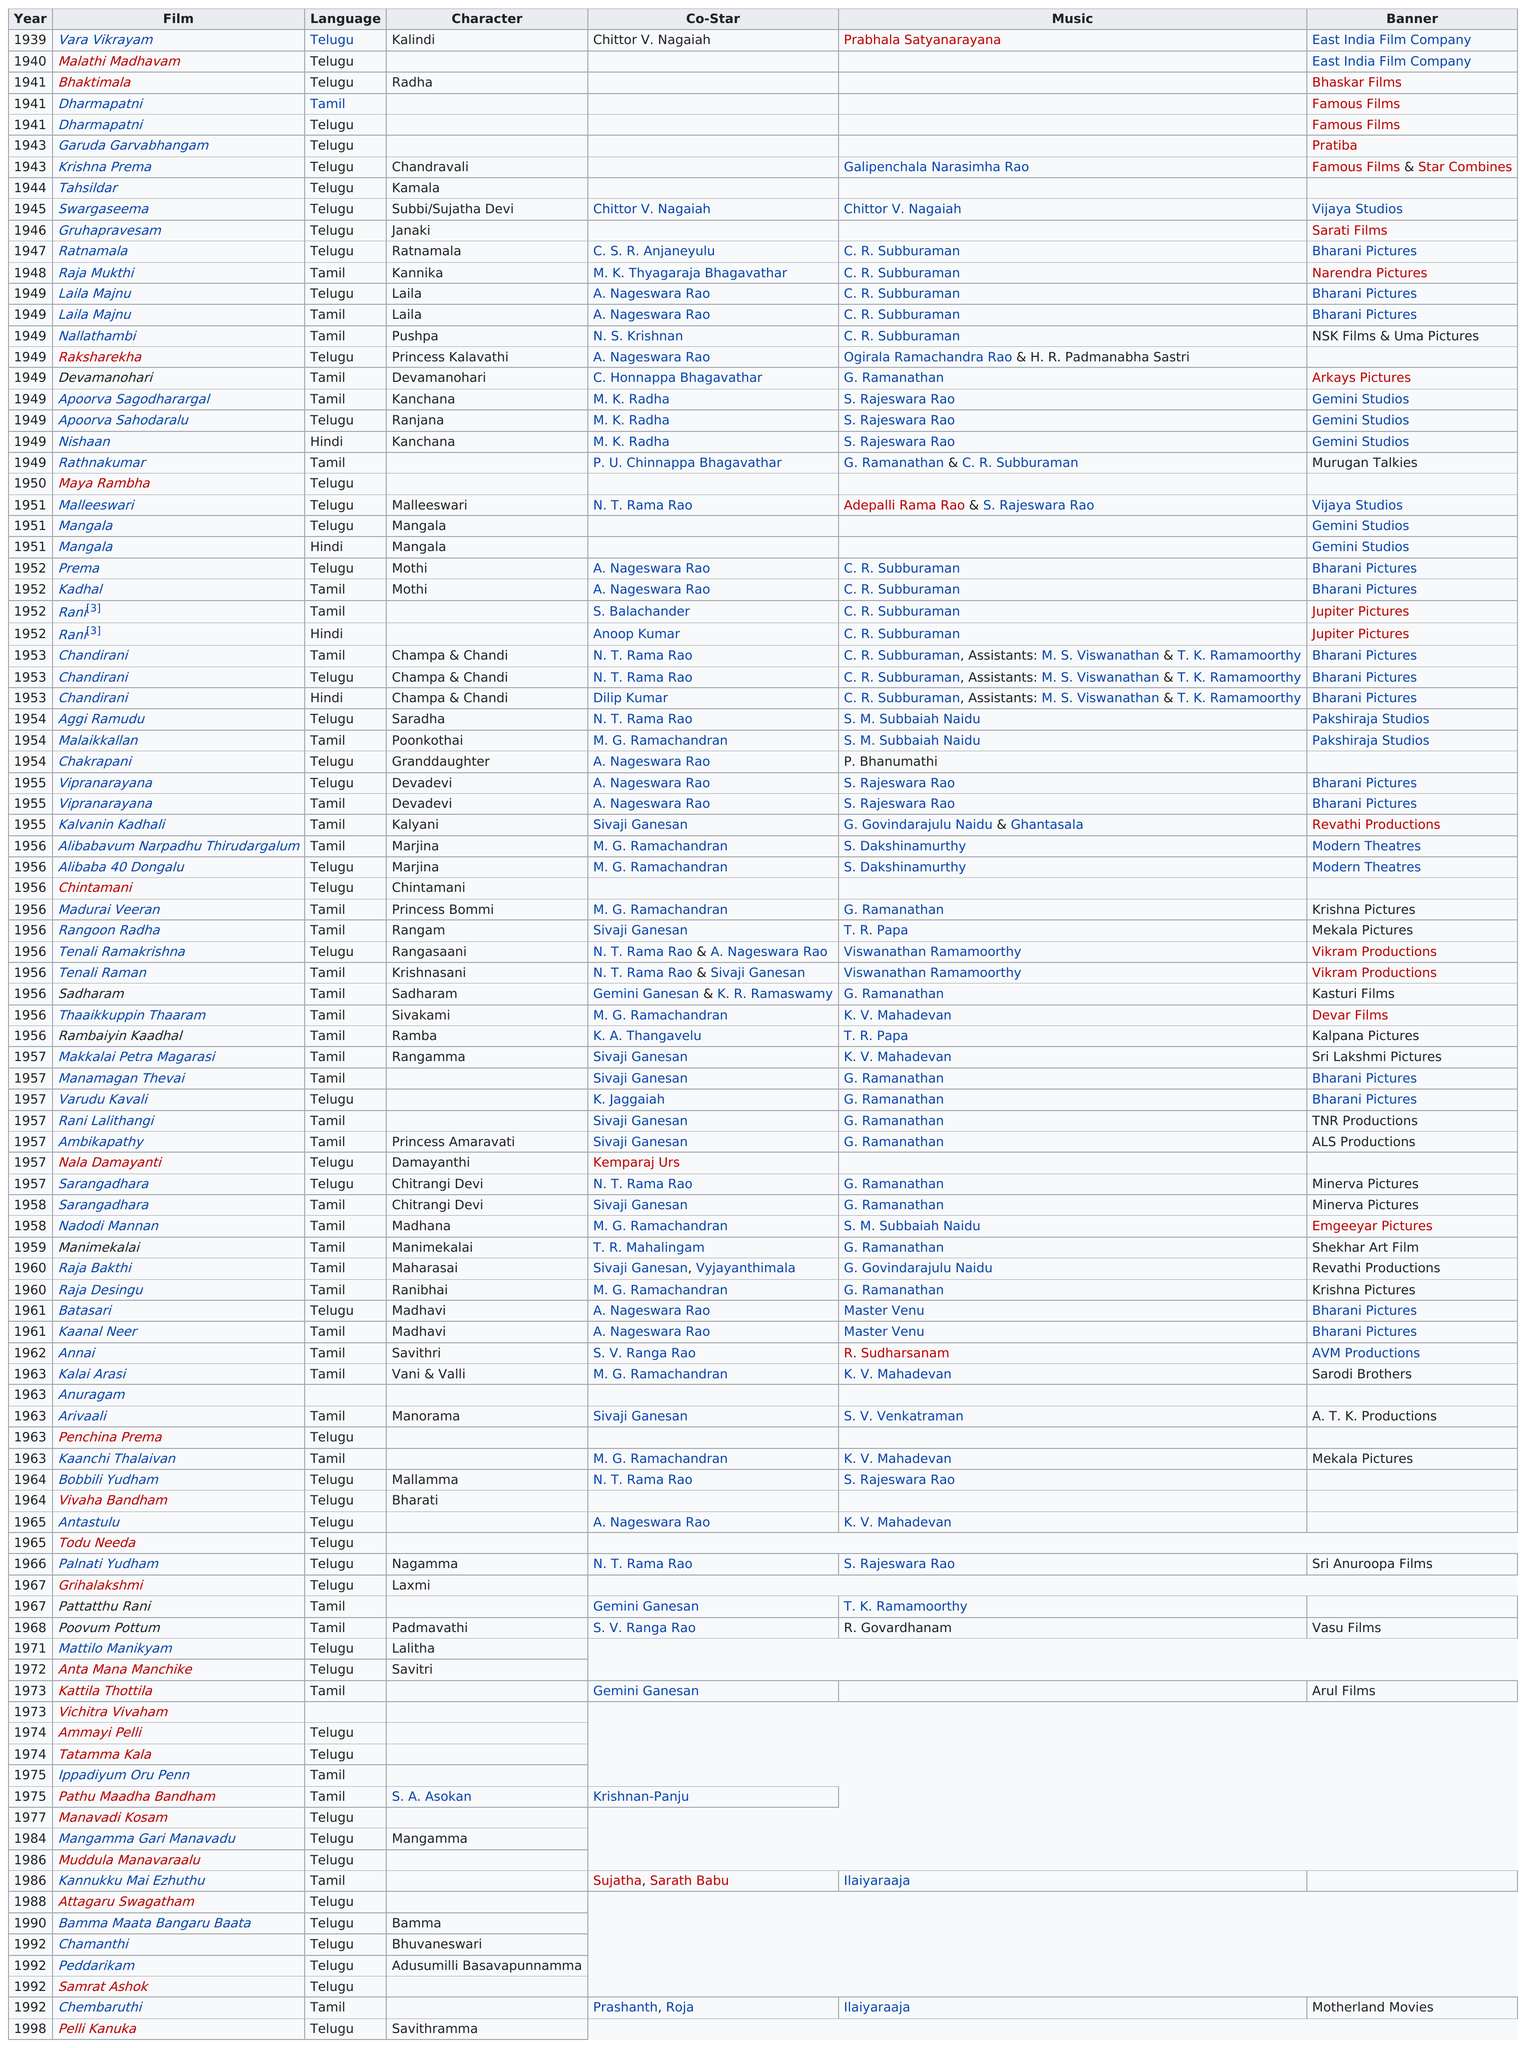Draw attention to some important aspects in this diagram. During the 1990s, a total of 6 films were produced. The name of the last movie the actress appeared in was "Pelli Kanuka. The actress starred in the movie after "Krishna Prema" which was titled "Tahsildar.. The actress filmed movies in a total of 3 different languages. The actress appeared in three films in 1941. 